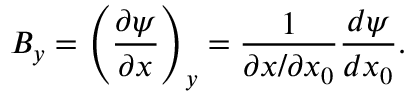<formula> <loc_0><loc_0><loc_500><loc_500>B _ { y } = \left ( \frac { \partial \psi } { \partial x } \right ) _ { y } = \frac { 1 } { \partial x / \partial x _ { 0 } } \frac { d \psi } { d x _ { 0 } } .</formula> 